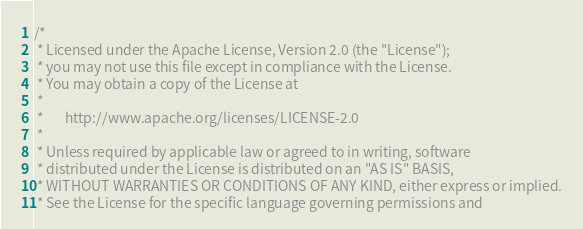<code> <loc_0><loc_0><loc_500><loc_500><_Scala_>/*
 * Licensed under the Apache License, Version 2.0 (the "License");
 * you may not use this file except in compliance with the License.
 * You may obtain a copy of the License at
 *
 *       http://www.apache.org/licenses/LICENSE-2.0
 *
 * Unless required by applicable law or agreed to in writing, software
 * distributed under the License is distributed on an "AS IS" BASIS,
 * WITHOUT WARRANTIES OR CONDITIONS OF ANY KIND, either express or implied.
 * See the License for the specific language governing permissions and</code> 